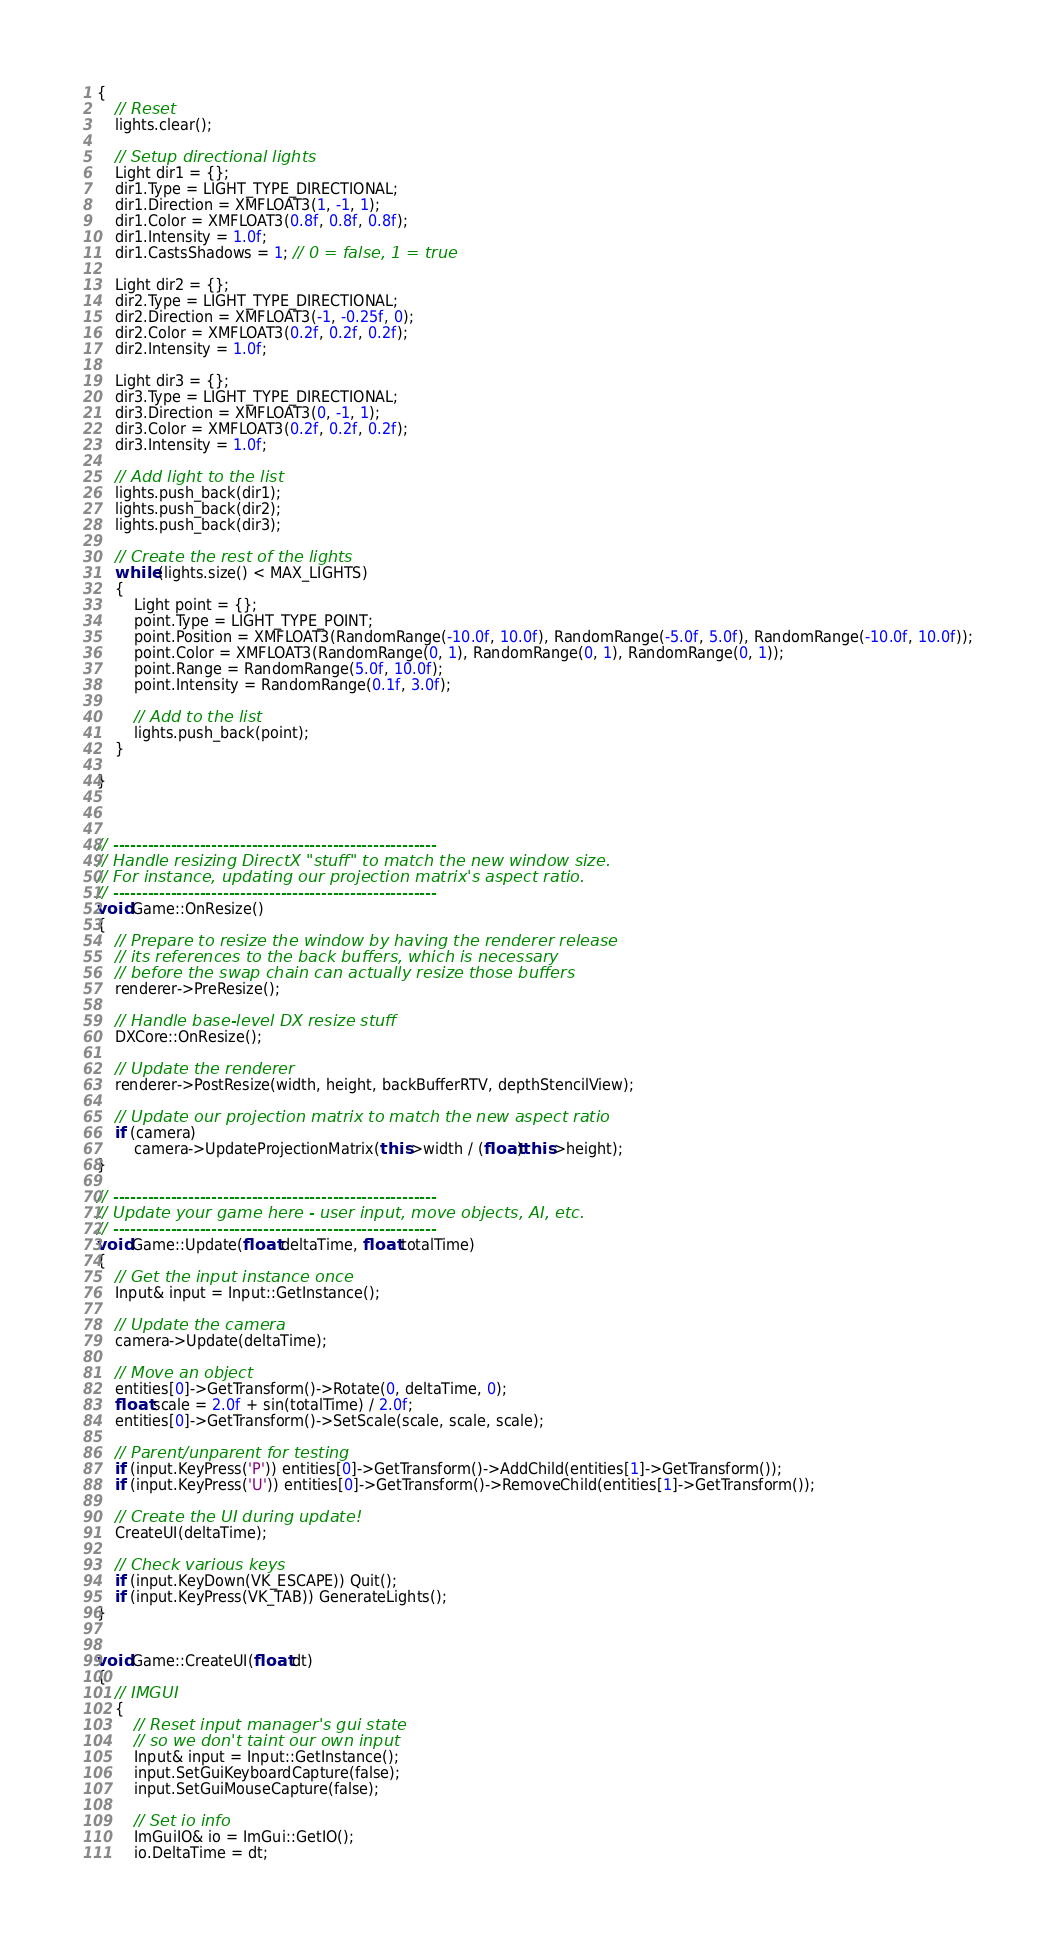<code> <loc_0><loc_0><loc_500><loc_500><_C++_>{
	// Reset
	lights.clear();

	// Setup directional lights
	Light dir1 = {};
	dir1.Type = LIGHT_TYPE_DIRECTIONAL;
	dir1.Direction = XMFLOAT3(1, -1, 1);
	dir1.Color = XMFLOAT3(0.8f, 0.8f, 0.8f);
	dir1.Intensity = 1.0f;
	dir1.CastsShadows = 1; // 0 = false, 1 = true

	Light dir2 = {};
	dir2.Type = LIGHT_TYPE_DIRECTIONAL;
	dir2.Direction = XMFLOAT3(-1, -0.25f, 0);
	dir2.Color = XMFLOAT3(0.2f, 0.2f, 0.2f);
	dir2.Intensity = 1.0f;

	Light dir3 = {};
	dir3.Type = LIGHT_TYPE_DIRECTIONAL;
	dir3.Direction = XMFLOAT3(0, -1, 1);
	dir3.Color = XMFLOAT3(0.2f, 0.2f, 0.2f);
	dir3.Intensity = 1.0f;

	// Add light to the list
	lights.push_back(dir1);
	lights.push_back(dir2);
	lights.push_back(dir3);

	// Create the rest of the lights
	while (lights.size() < MAX_LIGHTS)
	{
		Light point = {};
		point.Type = LIGHT_TYPE_POINT;
		point.Position = XMFLOAT3(RandomRange(-10.0f, 10.0f), RandomRange(-5.0f, 5.0f), RandomRange(-10.0f, 10.0f));
		point.Color = XMFLOAT3(RandomRange(0, 1), RandomRange(0, 1), RandomRange(0, 1));
		point.Range = RandomRange(5.0f, 10.0f);
		point.Intensity = RandomRange(0.1f, 3.0f);

		// Add to the list
		lights.push_back(point);
	}

}



// --------------------------------------------------------
// Handle resizing DirectX "stuff" to match the new window size.
// For instance, updating our projection matrix's aspect ratio.
// --------------------------------------------------------
void Game::OnResize()
{
	// Prepare to resize the window by having the renderer release
	// its references to the back buffers, which is necessary
	// before the swap chain can actually resize those buffers
	renderer->PreResize();

	// Handle base-level DX resize stuff
	DXCore::OnResize();

	// Update the renderer
	renderer->PostResize(width, height, backBufferRTV, depthStencilView);

	// Update our projection matrix to match the new aspect ratio
	if (camera)
		camera->UpdateProjectionMatrix(this->width / (float)this->height);
}

// --------------------------------------------------------
// Update your game here - user input, move objects, AI, etc.
// --------------------------------------------------------
void Game::Update(float deltaTime, float totalTime)
{
	// Get the input instance once
	Input& input = Input::GetInstance();

	// Update the camera
	camera->Update(deltaTime);

	// Move an object
	entities[0]->GetTransform()->Rotate(0, deltaTime, 0);
	float scale = 2.0f + sin(totalTime) / 2.0f;
	entities[0]->GetTransform()->SetScale(scale, scale, scale);

	// Parent/unparent for testing
	if (input.KeyPress('P')) entities[0]->GetTransform()->AddChild(entities[1]->GetTransform());
	if (input.KeyPress('U')) entities[0]->GetTransform()->RemoveChild(entities[1]->GetTransform());

	// Create the UI during update!
	CreateUI(deltaTime);

	// Check various keys
	if (input.KeyDown(VK_ESCAPE)) Quit();
	if (input.KeyPress(VK_TAB)) GenerateLights();
}


void Game::CreateUI(float dt)
{
	// IMGUI
	{
		// Reset input manager's gui state
		// so we don't taint our own input
		Input& input = Input::GetInstance();
		input.SetGuiKeyboardCapture(false);
		input.SetGuiMouseCapture(false);

		// Set io info
		ImGuiIO& io = ImGui::GetIO();
		io.DeltaTime = dt;</code> 